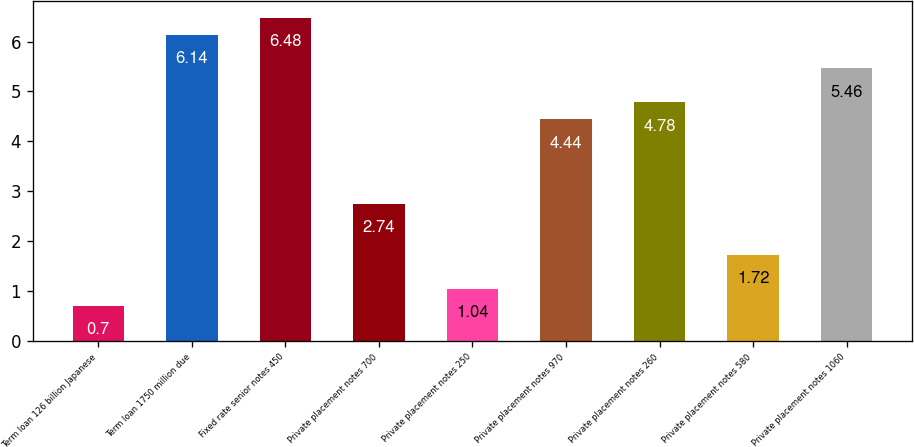Convert chart to OTSL. <chart><loc_0><loc_0><loc_500><loc_500><bar_chart><fcel>Term loan 126 billion Japanese<fcel>Term loan 1750 million due<fcel>Fixed rate senior notes 450<fcel>Private placement notes 700<fcel>Private placement notes 250<fcel>Private placement notes 970<fcel>Private placement notes 260<fcel>Private placement notes 580<fcel>Private placement notes 1060<nl><fcel>0.7<fcel>6.14<fcel>6.48<fcel>2.74<fcel>1.04<fcel>4.44<fcel>4.78<fcel>1.72<fcel>5.46<nl></chart> 